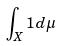<formula> <loc_0><loc_0><loc_500><loc_500>\int _ { X } 1 d \mu</formula> 